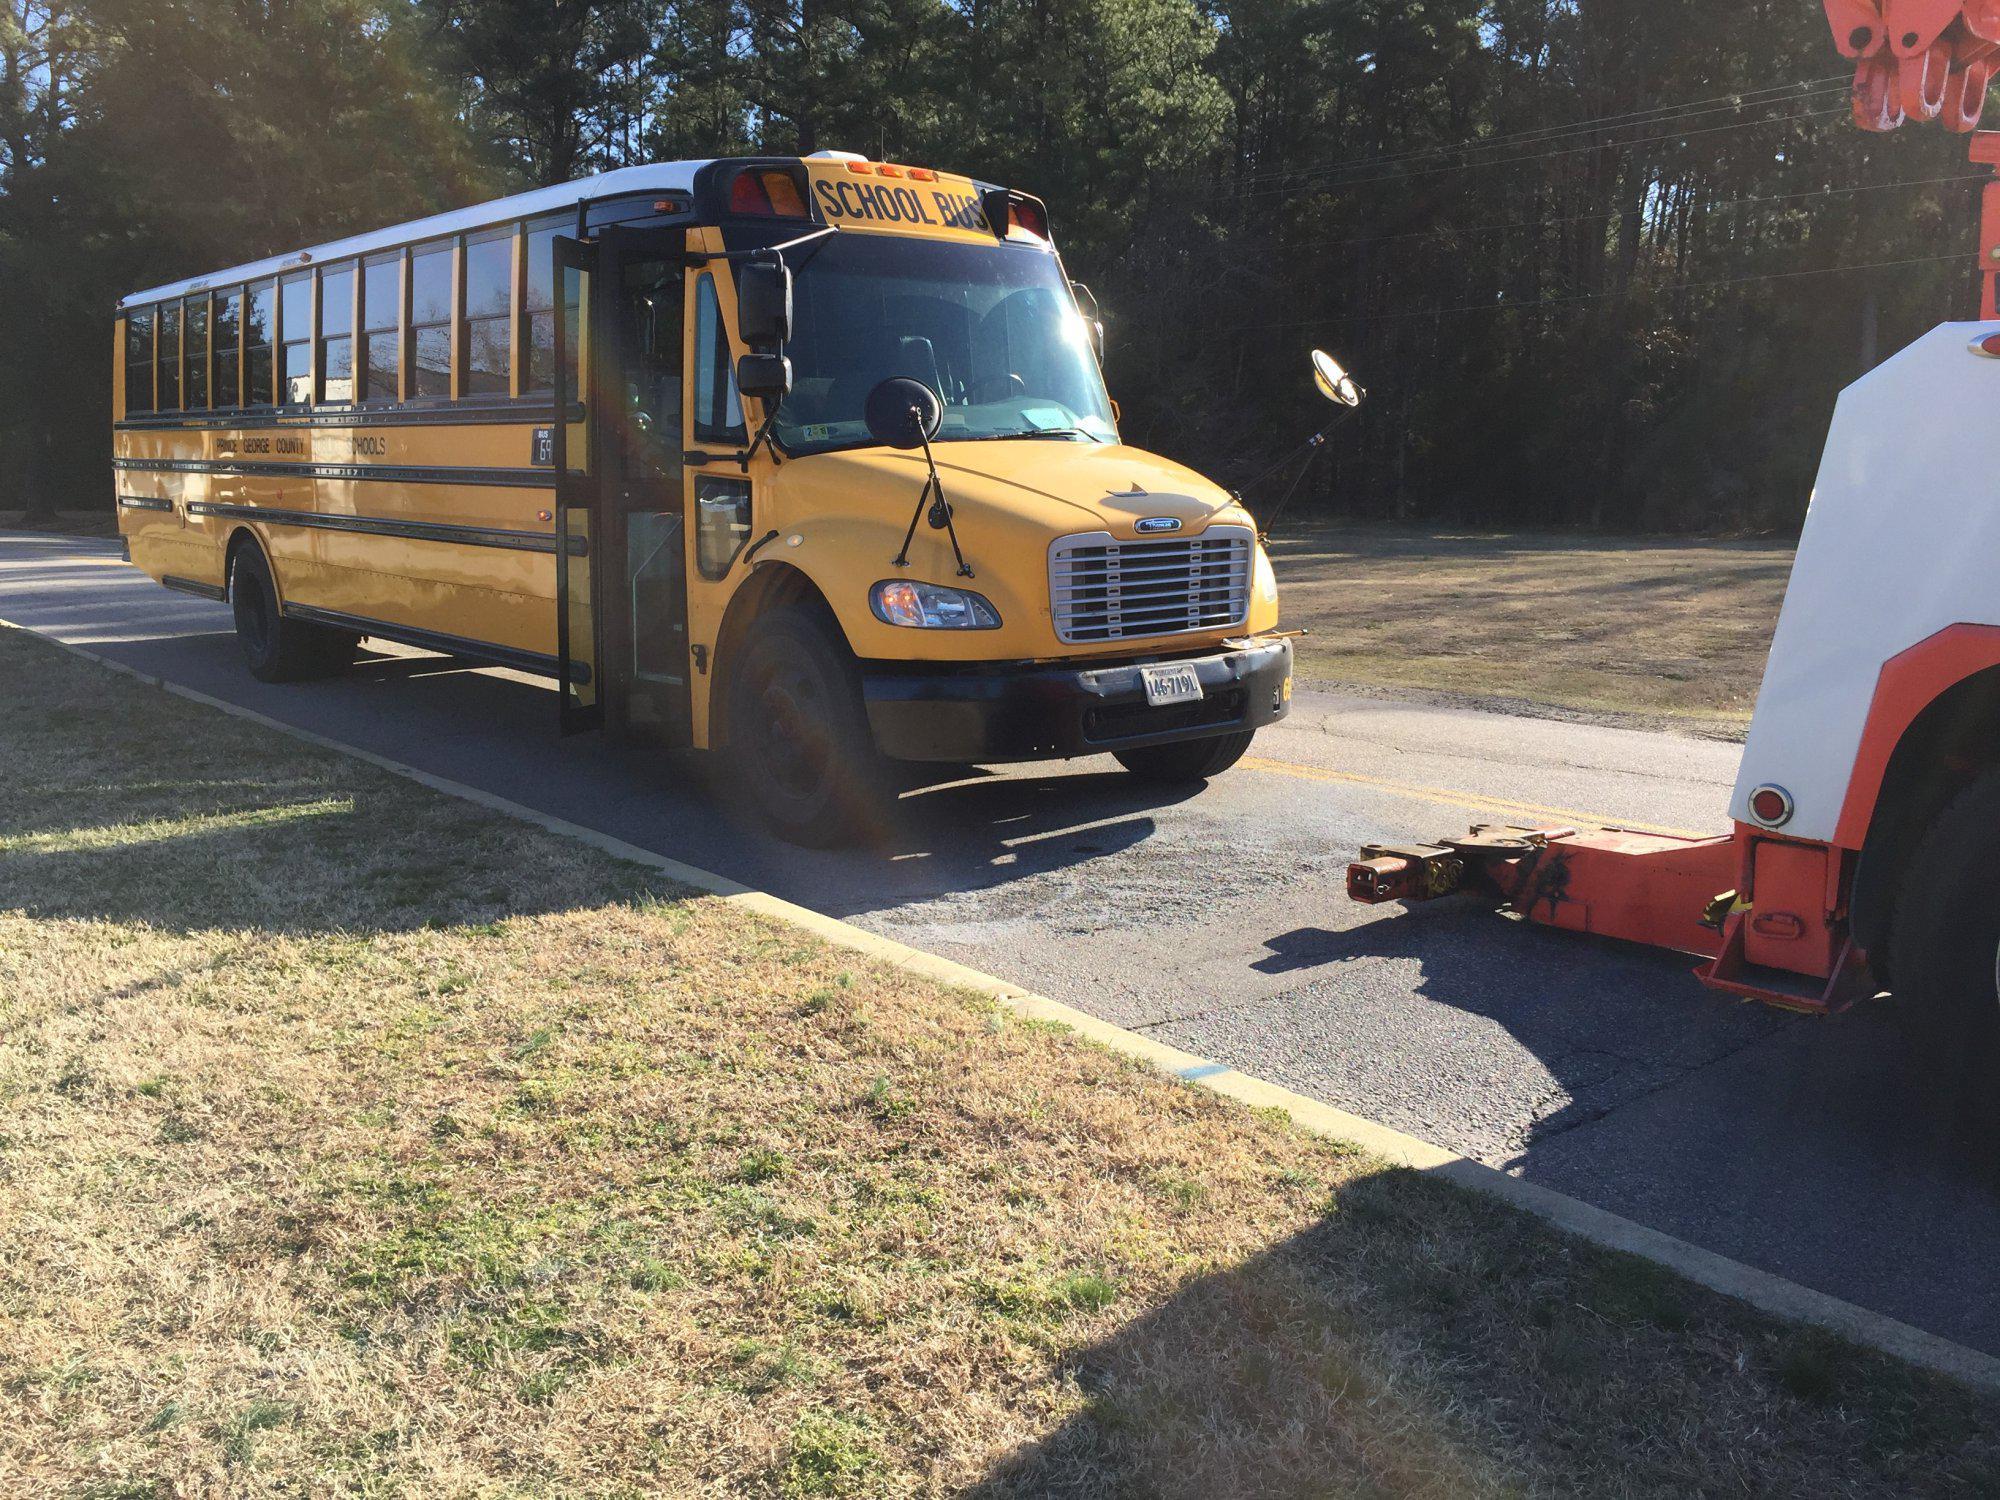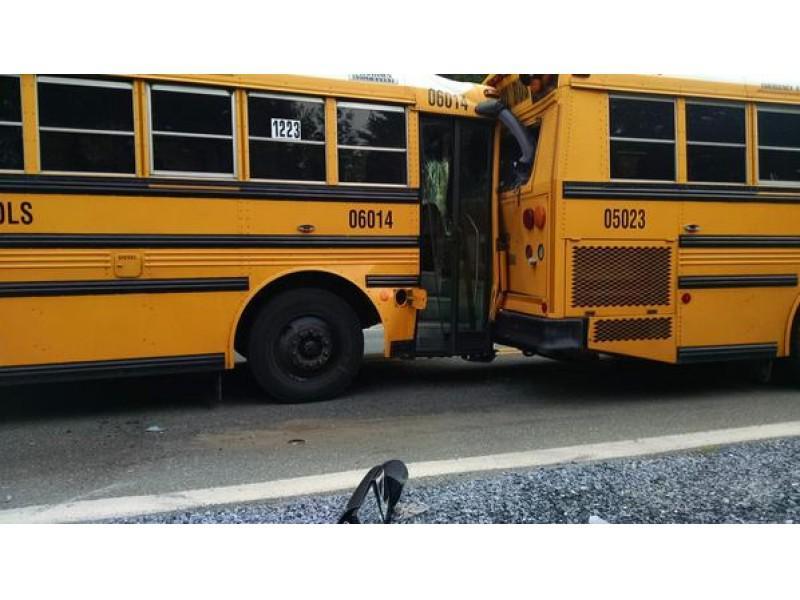The first image is the image on the left, the second image is the image on the right. For the images displayed, is the sentence "In the right image, a rightward-facing yellow bus appears to be colliding with something else that is yellow." factually correct? Answer yes or no. Yes. The first image is the image on the left, the second image is the image on the right. For the images shown, is this caption "There are two parallel buses facing left and forward." true? Answer yes or no. No. 